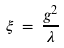<formula> <loc_0><loc_0><loc_500><loc_500>\xi \, = \, \frac { g ^ { 2 } } { \lambda }</formula> 